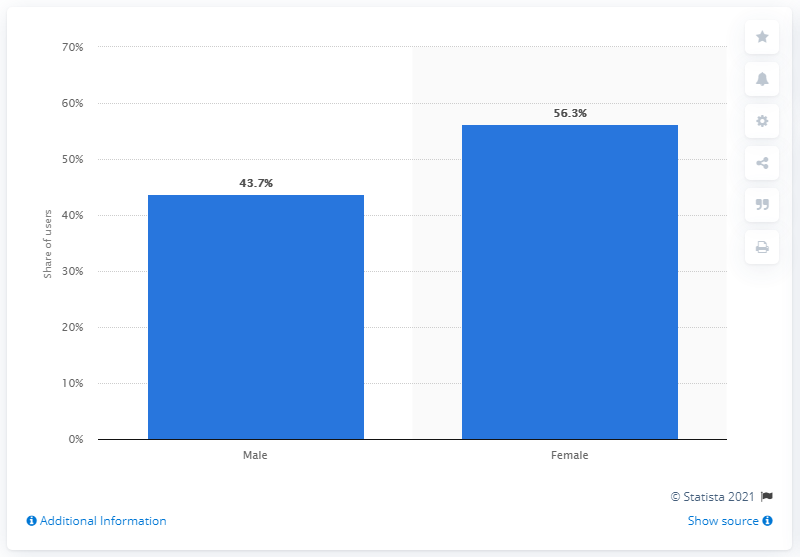Outline some significant characteristics in this image. According to App Ape, 43.7% of Instagram's users were male. As of January 2021, approximately 56.3% of Instagram's active users were female. 